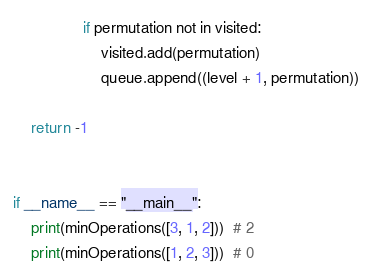<code> <loc_0><loc_0><loc_500><loc_500><_Python_>                if permutation not in visited:
                    visited.add(permutation)
                    queue.append((level + 1, permutation))

    return -1


if __name__ == "__main__":
    print(minOperations([3, 1, 2]))  # 2
    print(minOperations([1, 2, 3]))  # 0
</code> 